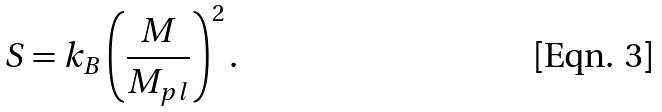Convert formula to latex. <formula><loc_0><loc_0><loc_500><loc_500>S = k _ { B } \left ( \frac { M } { M _ { p l } } \right ) ^ { 2 } .</formula> 